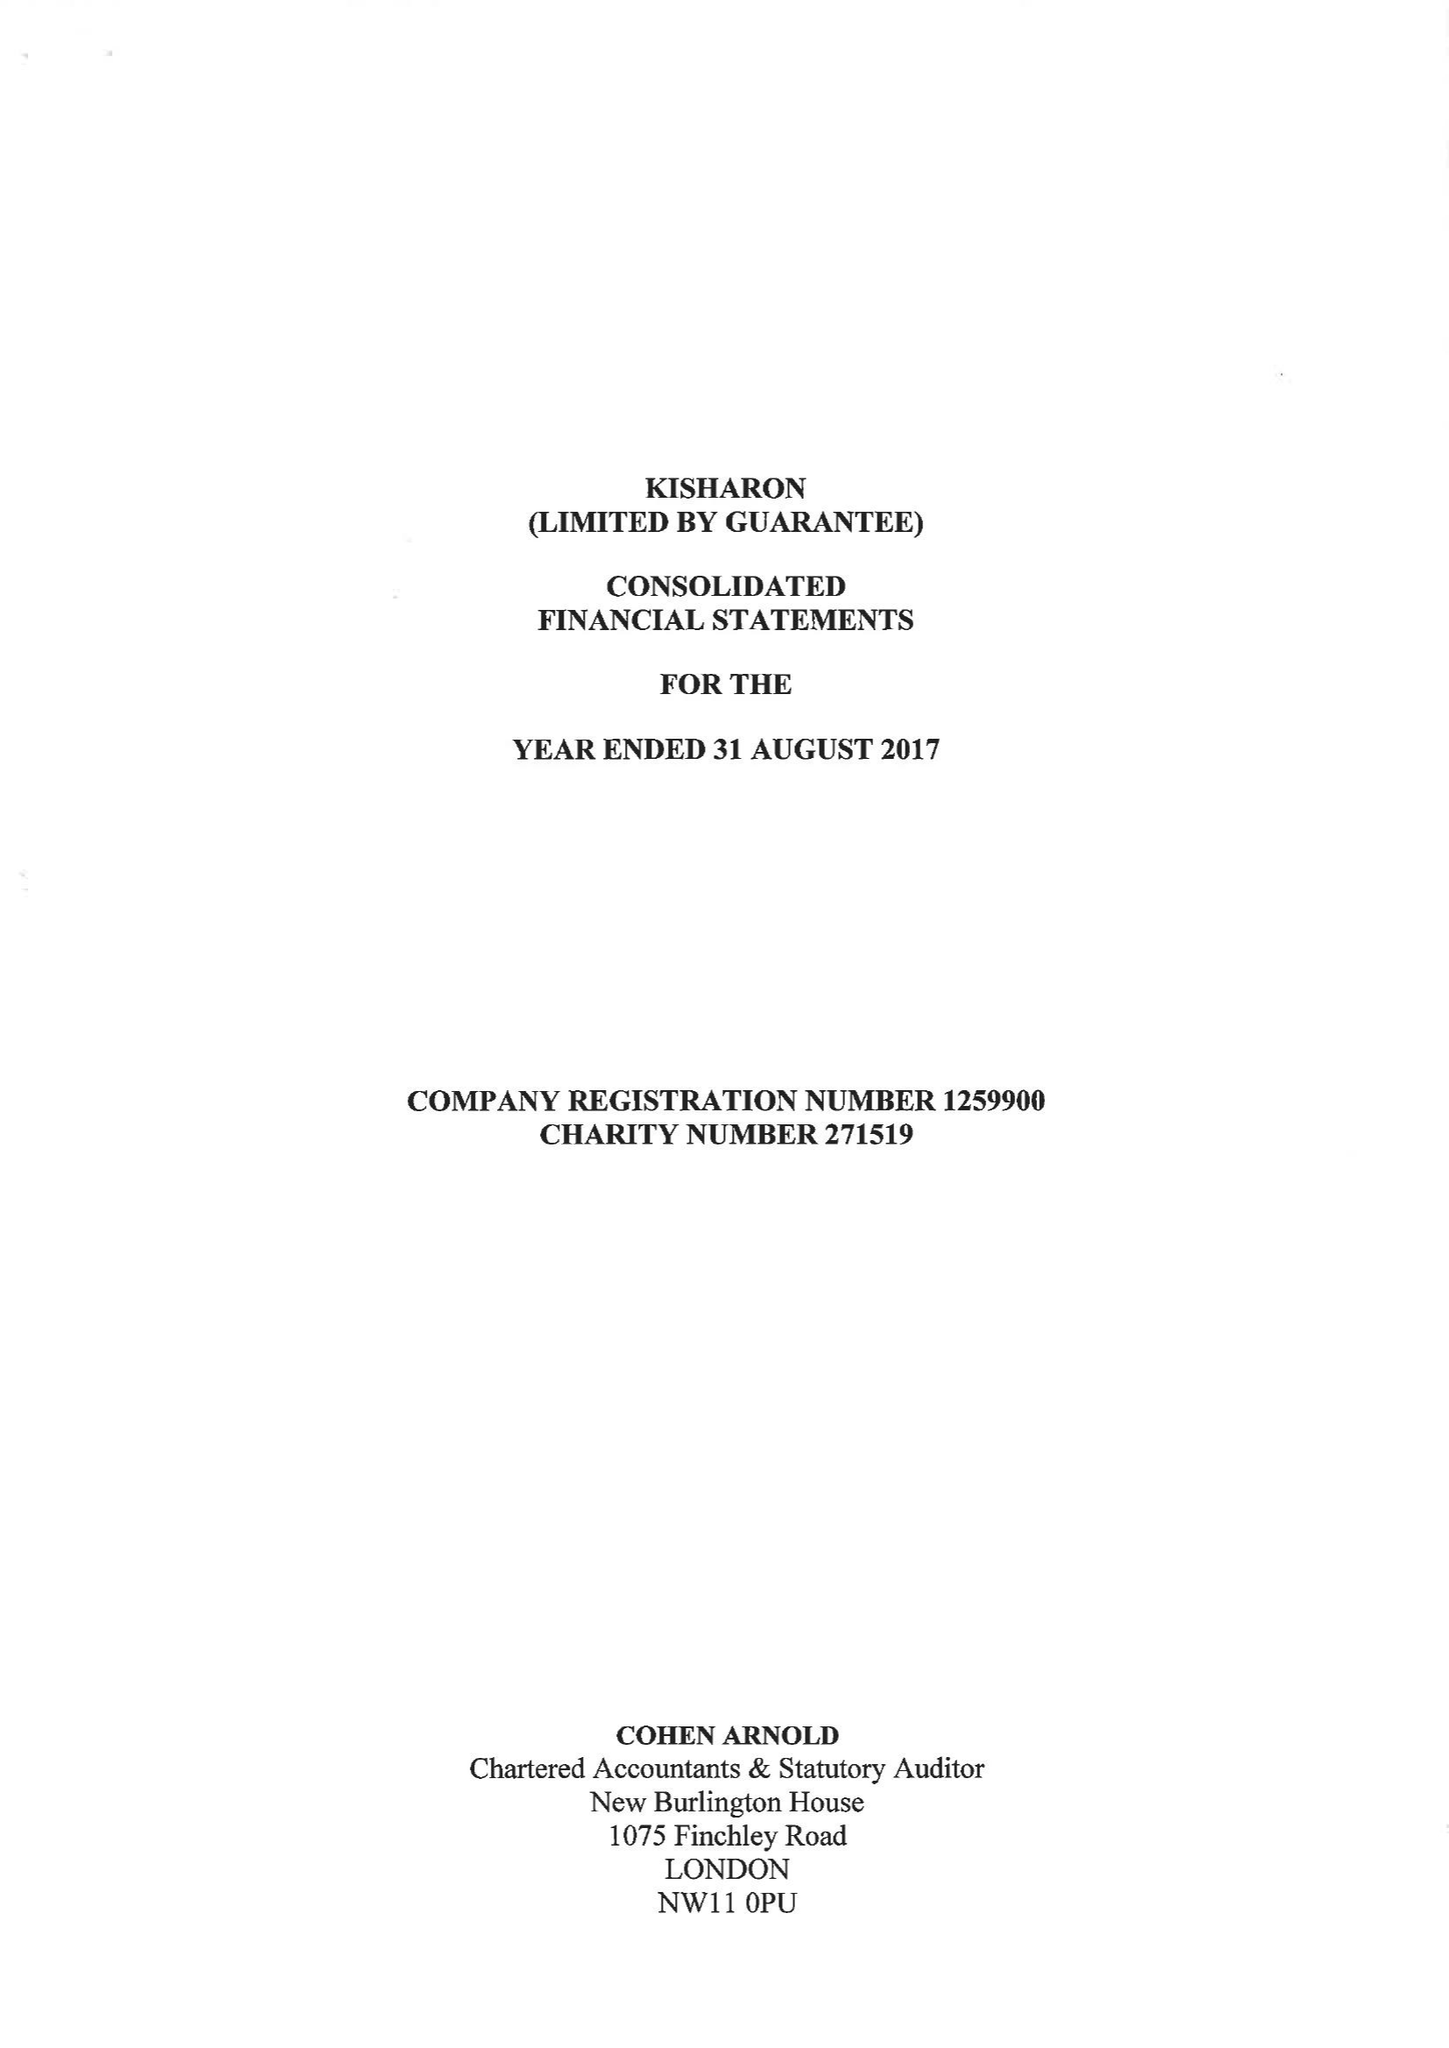What is the value for the address__street_line?
Answer the question using a single word or phrase. 333 EDGWARE ROAD 